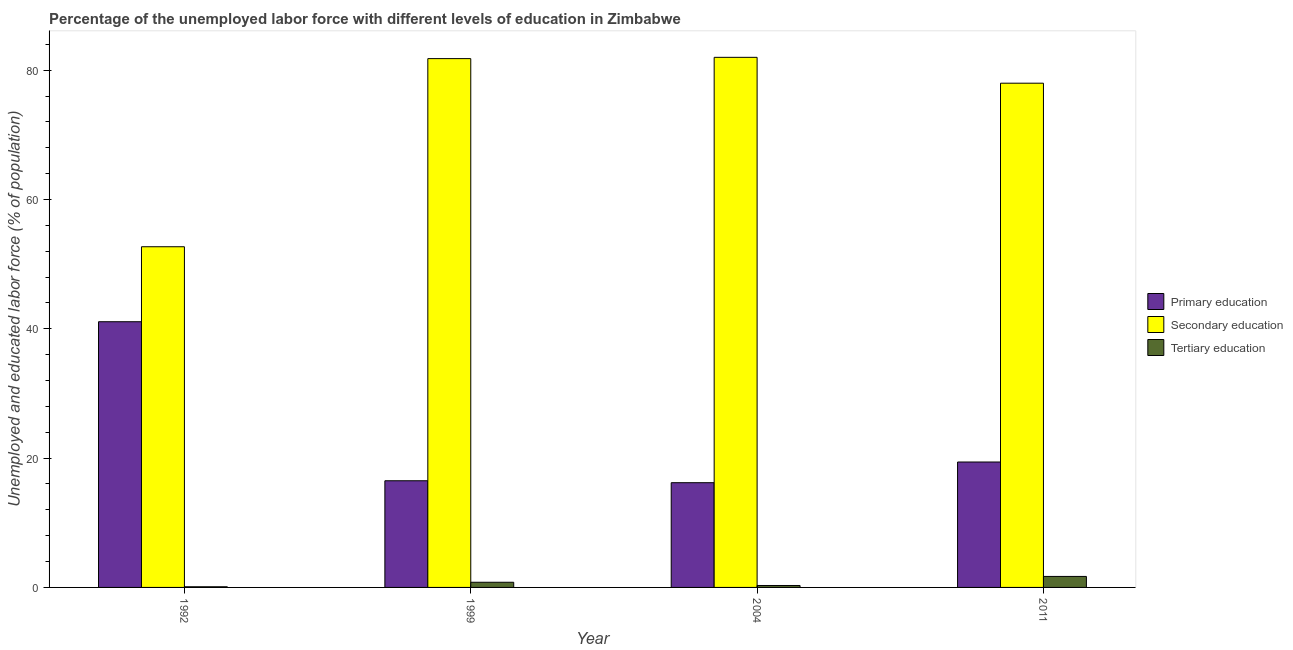Are the number of bars per tick equal to the number of legend labels?
Your answer should be very brief. Yes. Are the number of bars on each tick of the X-axis equal?
Offer a terse response. Yes. What is the label of the 2nd group of bars from the left?
Provide a short and direct response. 1999. In how many cases, is the number of bars for a given year not equal to the number of legend labels?
Provide a succinct answer. 0. What is the percentage of labor force who received tertiary education in 1992?
Make the answer very short. 0.1. Across all years, what is the maximum percentage of labor force who received tertiary education?
Your response must be concise. 1.7. Across all years, what is the minimum percentage of labor force who received tertiary education?
Keep it short and to the point. 0.1. In which year was the percentage of labor force who received primary education maximum?
Provide a succinct answer. 1992. What is the total percentage of labor force who received secondary education in the graph?
Offer a terse response. 294.5. What is the difference between the percentage of labor force who received secondary education in 1992 and that in 2011?
Keep it short and to the point. -25.3. What is the difference between the percentage of labor force who received tertiary education in 1999 and the percentage of labor force who received primary education in 2004?
Your response must be concise. 0.5. What is the average percentage of labor force who received tertiary education per year?
Ensure brevity in your answer.  0.73. In how many years, is the percentage of labor force who received primary education greater than 40 %?
Your response must be concise. 1. What is the ratio of the percentage of labor force who received primary education in 1992 to that in 1999?
Ensure brevity in your answer.  2.49. Is the percentage of labor force who received primary education in 1999 less than that in 2004?
Your answer should be compact. No. Is the difference between the percentage of labor force who received secondary education in 2004 and 2011 greater than the difference between the percentage of labor force who received tertiary education in 2004 and 2011?
Your response must be concise. No. What is the difference between the highest and the second highest percentage of labor force who received primary education?
Offer a terse response. 21.7. What is the difference between the highest and the lowest percentage of labor force who received primary education?
Your answer should be very brief. 24.9. Is the sum of the percentage of labor force who received secondary education in 2004 and 2011 greater than the maximum percentage of labor force who received primary education across all years?
Your answer should be very brief. Yes. What does the 3rd bar from the left in 1992 represents?
Your answer should be very brief. Tertiary education. How many bars are there?
Provide a succinct answer. 12. Does the graph contain any zero values?
Your answer should be compact. No. Does the graph contain grids?
Your answer should be compact. No. Where does the legend appear in the graph?
Your answer should be very brief. Center right. What is the title of the graph?
Keep it short and to the point. Percentage of the unemployed labor force with different levels of education in Zimbabwe. What is the label or title of the X-axis?
Make the answer very short. Year. What is the label or title of the Y-axis?
Ensure brevity in your answer.  Unemployed and educated labor force (% of population). What is the Unemployed and educated labor force (% of population) of Primary education in 1992?
Provide a succinct answer. 41.1. What is the Unemployed and educated labor force (% of population) of Secondary education in 1992?
Ensure brevity in your answer.  52.7. What is the Unemployed and educated labor force (% of population) of Tertiary education in 1992?
Make the answer very short. 0.1. What is the Unemployed and educated labor force (% of population) of Secondary education in 1999?
Keep it short and to the point. 81.8. What is the Unemployed and educated labor force (% of population) of Tertiary education in 1999?
Offer a terse response. 0.8. What is the Unemployed and educated labor force (% of population) of Primary education in 2004?
Provide a succinct answer. 16.2. What is the Unemployed and educated labor force (% of population) of Tertiary education in 2004?
Your response must be concise. 0.3. What is the Unemployed and educated labor force (% of population) in Primary education in 2011?
Provide a short and direct response. 19.4. What is the Unemployed and educated labor force (% of population) of Secondary education in 2011?
Keep it short and to the point. 78. What is the Unemployed and educated labor force (% of population) in Tertiary education in 2011?
Your answer should be very brief. 1.7. Across all years, what is the maximum Unemployed and educated labor force (% of population) in Primary education?
Provide a short and direct response. 41.1. Across all years, what is the maximum Unemployed and educated labor force (% of population) in Secondary education?
Your answer should be very brief. 82. Across all years, what is the maximum Unemployed and educated labor force (% of population) of Tertiary education?
Make the answer very short. 1.7. Across all years, what is the minimum Unemployed and educated labor force (% of population) in Primary education?
Provide a succinct answer. 16.2. Across all years, what is the minimum Unemployed and educated labor force (% of population) in Secondary education?
Make the answer very short. 52.7. Across all years, what is the minimum Unemployed and educated labor force (% of population) of Tertiary education?
Your answer should be very brief. 0.1. What is the total Unemployed and educated labor force (% of population) of Primary education in the graph?
Offer a very short reply. 93.2. What is the total Unemployed and educated labor force (% of population) in Secondary education in the graph?
Offer a very short reply. 294.5. What is the difference between the Unemployed and educated labor force (% of population) of Primary education in 1992 and that in 1999?
Your answer should be compact. 24.6. What is the difference between the Unemployed and educated labor force (% of population) in Secondary education in 1992 and that in 1999?
Give a very brief answer. -29.1. What is the difference between the Unemployed and educated labor force (% of population) of Primary education in 1992 and that in 2004?
Your response must be concise. 24.9. What is the difference between the Unemployed and educated labor force (% of population) of Secondary education in 1992 and that in 2004?
Your answer should be compact. -29.3. What is the difference between the Unemployed and educated labor force (% of population) of Tertiary education in 1992 and that in 2004?
Provide a succinct answer. -0.2. What is the difference between the Unemployed and educated labor force (% of population) of Primary education in 1992 and that in 2011?
Ensure brevity in your answer.  21.7. What is the difference between the Unemployed and educated labor force (% of population) in Secondary education in 1992 and that in 2011?
Keep it short and to the point. -25.3. What is the difference between the Unemployed and educated labor force (% of population) in Tertiary education in 1992 and that in 2011?
Your answer should be compact. -1.6. What is the difference between the Unemployed and educated labor force (% of population) of Primary education in 1999 and that in 2011?
Your response must be concise. -2.9. What is the difference between the Unemployed and educated labor force (% of population) of Primary education in 2004 and that in 2011?
Your answer should be compact. -3.2. What is the difference between the Unemployed and educated labor force (% of population) in Secondary education in 2004 and that in 2011?
Provide a short and direct response. 4. What is the difference between the Unemployed and educated labor force (% of population) of Primary education in 1992 and the Unemployed and educated labor force (% of population) of Secondary education in 1999?
Make the answer very short. -40.7. What is the difference between the Unemployed and educated labor force (% of population) in Primary education in 1992 and the Unemployed and educated labor force (% of population) in Tertiary education in 1999?
Offer a terse response. 40.3. What is the difference between the Unemployed and educated labor force (% of population) in Secondary education in 1992 and the Unemployed and educated labor force (% of population) in Tertiary education in 1999?
Keep it short and to the point. 51.9. What is the difference between the Unemployed and educated labor force (% of population) of Primary education in 1992 and the Unemployed and educated labor force (% of population) of Secondary education in 2004?
Your answer should be very brief. -40.9. What is the difference between the Unemployed and educated labor force (% of population) of Primary education in 1992 and the Unemployed and educated labor force (% of population) of Tertiary education in 2004?
Your answer should be compact. 40.8. What is the difference between the Unemployed and educated labor force (% of population) of Secondary education in 1992 and the Unemployed and educated labor force (% of population) of Tertiary education in 2004?
Your answer should be very brief. 52.4. What is the difference between the Unemployed and educated labor force (% of population) in Primary education in 1992 and the Unemployed and educated labor force (% of population) in Secondary education in 2011?
Your answer should be compact. -36.9. What is the difference between the Unemployed and educated labor force (% of population) of Primary education in 1992 and the Unemployed and educated labor force (% of population) of Tertiary education in 2011?
Keep it short and to the point. 39.4. What is the difference between the Unemployed and educated labor force (% of population) in Secondary education in 1992 and the Unemployed and educated labor force (% of population) in Tertiary education in 2011?
Ensure brevity in your answer.  51. What is the difference between the Unemployed and educated labor force (% of population) in Primary education in 1999 and the Unemployed and educated labor force (% of population) in Secondary education in 2004?
Provide a short and direct response. -65.5. What is the difference between the Unemployed and educated labor force (% of population) of Secondary education in 1999 and the Unemployed and educated labor force (% of population) of Tertiary education in 2004?
Provide a succinct answer. 81.5. What is the difference between the Unemployed and educated labor force (% of population) in Primary education in 1999 and the Unemployed and educated labor force (% of population) in Secondary education in 2011?
Offer a terse response. -61.5. What is the difference between the Unemployed and educated labor force (% of population) in Primary education in 1999 and the Unemployed and educated labor force (% of population) in Tertiary education in 2011?
Provide a short and direct response. 14.8. What is the difference between the Unemployed and educated labor force (% of population) in Secondary education in 1999 and the Unemployed and educated labor force (% of population) in Tertiary education in 2011?
Provide a short and direct response. 80.1. What is the difference between the Unemployed and educated labor force (% of population) of Primary education in 2004 and the Unemployed and educated labor force (% of population) of Secondary education in 2011?
Your answer should be compact. -61.8. What is the difference between the Unemployed and educated labor force (% of population) in Primary education in 2004 and the Unemployed and educated labor force (% of population) in Tertiary education in 2011?
Provide a succinct answer. 14.5. What is the difference between the Unemployed and educated labor force (% of population) of Secondary education in 2004 and the Unemployed and educated labor force (% of population) of Tertiary education in 2011?
Make the answer very short. 80.3. What is the average Unemployed and educated labor force (% of population) in Primary education per year?
Offer a terse response. 23.3. What is the average Unemployed and educated labor force (% of population) of Secondary education per year?
Give a very brief answer. 73.62. What is the average Unemployed and educated labor force (% of population) of Tertiary education per year?
Provide a short and direct response. 0.72. In the year 1992, what is the difference between the Unemployed and educated labor force (% of population) in Primary education and Unemployed and educated labor force (% of population) in Tertiary education?
Make the answer very short. 41. In the year 1992, what is the difference between the Unemployed and educated labor force (% of population) in Secondary education and Unemployed and educated labor force (% of population) in Tertiary education?
Make the answer very short. 52.6. In the year 1999, what is the difference between the Unemployed and educated labor force (% of population) in Primary education and Unemployed and educated labor force (% of population) in Secondary education?
Offer a very short reply. -65.3. In the year 1999, what is the difference between the Unemployed and educated labor force (% of population) in Primary education and Unemployed and educated labor force (% of population) in Tertiary education?
Provide a short and direct response. 15.7. In the year 2004, what is the difference between the Unemployed and educated labor force (% of population) of Primary education and Unemployed and educated labor force (% of population) of Secondary education?
Your answer should be compact. -65.8. In the year 2004, what is the difference between the Unemployed and educated labor force (% of population) of Secondary education and Unemployed and educated labor force (% of population) of Tertiary education?
Provide a succinct answer. 81.7. In the year 2011, what is the difference between the Unemployed and educated labor force (% of population) of Primary education and Unemployed and educated labor force (% of population) of Secondary education?
Make the answer very short. -58.6. In the year 2011, what is the difference between the Unemployed and educated labor force (% of population) of Secondary education and Unemployed and educated labor force (% of population) of Tertiary education?
Make the answer very short. 76.3. What is the ratio of the Unemployed and educated labor force (% of population) in Primary education in 1992 to that in 1999?
Make the answer very short. 2.49. What is the ratio of the Unemployed and educated labor force (% of population) in Secondary education in 1992 to that in 1999?
Your answer should be compact. 0.64. What is the ratio of the Unemployed and educated labor force (% of population) in Tertiary education in 1992 to that in 1999?
Your answer should be very brief. 0.12. What is the ratio of the Unemployed and educated labor force (% of population) in Primary education in 1992 to that in 2004?
Provide a short and direct response. 2.54. What is the ratio of the Unemployed and educated labor force (% of population) of Secondary education in 1992 to that in 2004?
Provide a succinct answer. 0.64. What is the ratio of the Unemployed and educated labor force (% of population) in Primary education in 1992 to that in 2011?
Offer a terse response. 2.12. What is the ratio of the Unemployed and educated labor force (% of population) of Secondary education in 1992 to that in 2011?
Your answer should be compact. 0.68. What is the ratio of the Unemployed and educated labor force (% of population) in Tertiary education in 1992 to that in 2011?
Provide a succinct answer. 0.06. What is the ratio of the Unemployed and educated labor force (% of population) in Primary education in 1999 to that in 2004?
Your answer should be compact. 1.02. What is the ratio of the Unemployed and educated labor force (% of population) in Tertiary education in 1999 to that in 2004?
Keep it short and to the point. 2.67. What is the ratio of the Unemployed and educated labor force (% of population) of Primary education in 1999 to that in 2011?
Keep it short and to the point. 0.85. What is the ratio of the Unemployed and educated labor force (% of population) of Secondary education in 1999 to that in 2011?
Offer a terse response. 1.05. What is the ratio of the Unemployed and educated labor force (% of population) in Tertiary education in 1999 to that in 2011?
Provide a succinct answer. 0.47. What is the ratio of the Unemployed and educated labor force (% of population) of Primary education in 2004 to that in 2011?
Your answer should be very brief. 0.84. What is the ratio of the Unemployed and educated labor force (% of population) in Secondary education in 2004 to that in 2011?
Keep it short and to the point. 1.05. What is the ratio of the Unemployed and educated labor force (% of population) in Tertiary education in 2004 to that in 2011?
Your answer should be compact. 0.18. What is the difference between the highest and the second highest Unemployed and educated labor force (% of population) in Primary education?
Provide a short and direct response. 21.7. What is the difference between the highest and the second highest Unemployed and educated labor force (% of population) of Secondary education?
Give a very brief answer. 0.2. What is the difference between the highest and the second highest Unemployed and educated labor force (% of population) in Tertiary education?
Offer a very short reply. 0.9. What is the difference between the highest and the lowest Unemployed and educated labor force (% of population) of Primary education?
Provide a succinct answer. 24.9. What is the difference between the highest and the lowest Unemployed and educated labor force (% of population) of Secondary education?
Keep it short and to the point. 29.3. 